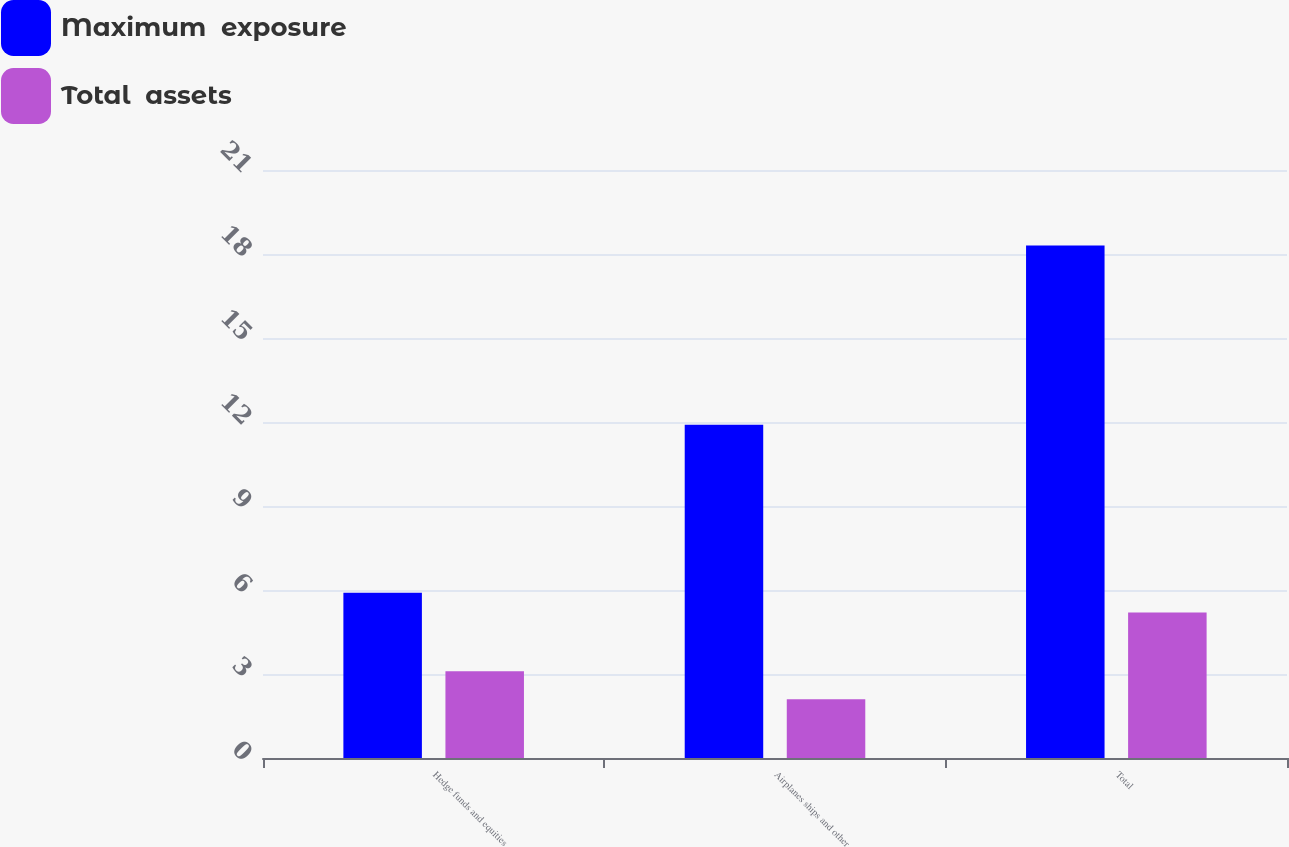Convert chart to OTSL. <chart><loc_0><loc_0><loc_500><loc_500><stacked_bar_chart><ecel><fcel>Hedge funds and equities<fcel>Airplanes ships and other<fcel>Total<nl><fcel>Maximum  exposure<fcel>5.9<fcel>11.9<fcel>18.3<nl><fcel>Total  assets<fcel>3.1<fcel>2.1<fcel>5.2<nl></chart> 